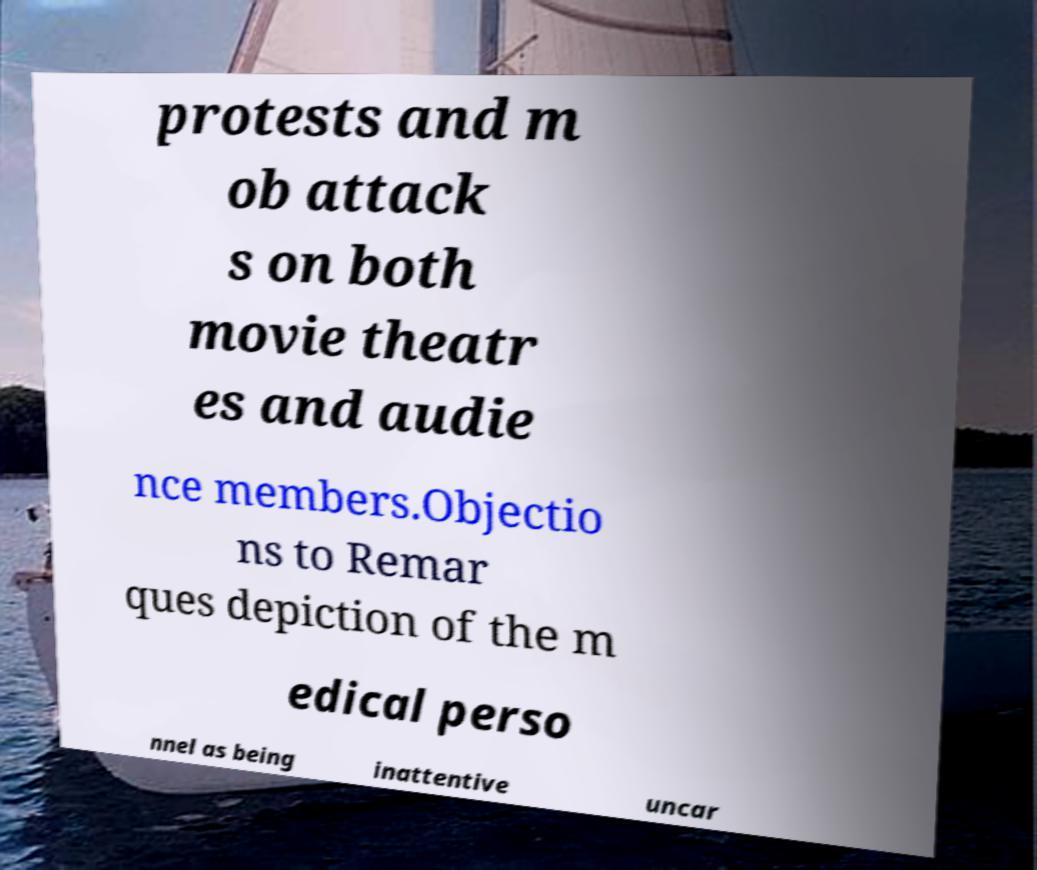Can you accurately transcribe the text from the provided image for me? protests and m ob attack s on both movie theatr es and audie nce members.Objectio ns to Remar ques depiction of the m edical perso nnel as being inattentive uncar 